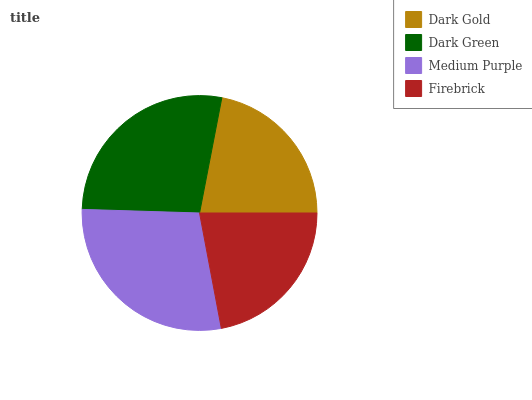Is Dark Gold the minimum?
Answer yes or no. Yes. Is Medium Purple the maximum?
Answer yes or no. Yes. Is Dark Green the minimum?
Answer yes or no. No. Is Dark Green the maximum?
Answer yes or no. No. Is Dark Green greater than Dark Gold?
Answer yes or no. Yes. Is Dark Gold less than Dark Green?
Answer yes or no. Yes. Is Dark Gold greater than Dark Green?
Answer yes or no. No. Is Dark Green less than Dark Gold?
Answer yes or no. No. Is Dark Green the high median?
Answer yes or no. Yes. Is Firebrick the low median?
Answer yes or no. Yes. Is Medium Purple the high median?
Answer yes or no. No. Is Medium Purple the low median?
Answer yes or no. No. 